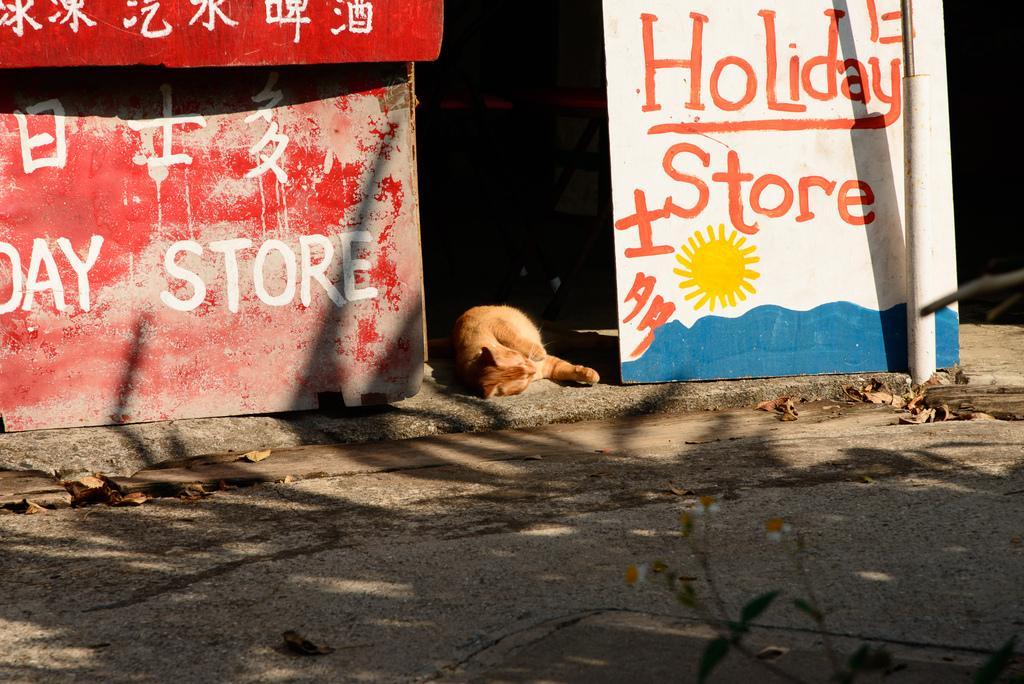In one or two sentences, can you explain what this image depicts? In this image we can see the hoardings with text. We can also see a cat sleeping on the surface. At the bottom we can see some dried leaves on the road. 